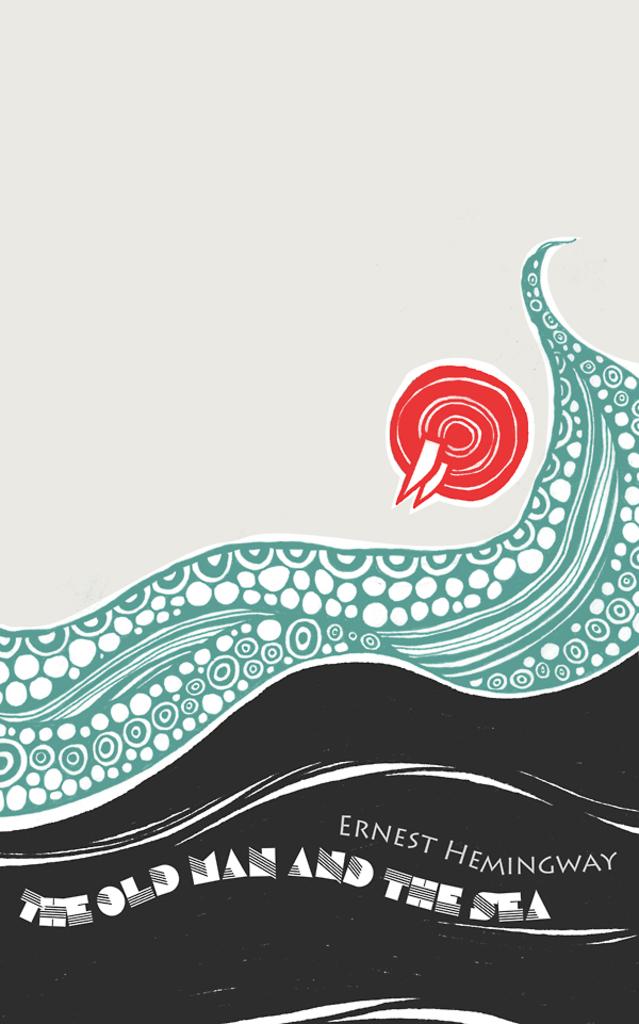Who is the author of the book?
Make the answer very short. Ernest hemingway. What is the name of this book?
Make the answer very short. The old man and the sea. 